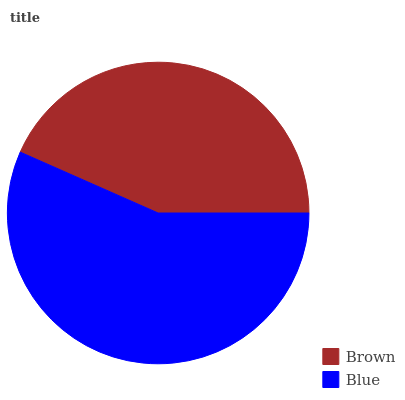Is Brown the minimum?
Answer yes or no. Yes. Is Blue the maximum?
Answer yes or no. Yes. Is Blue the minimum?
Answer yes or no. No. Is Blue greater than Brown?
Answer yes or no. Yes. Is Brown less than Blue?
Answer yes or no. Yes. Is Brown greater than Blue?
Answer yes or no. No. Is Blue less than Brown?
Answer yes or no. No. Is Blue the high median?
Answer yes or no. Yes. Is Brown the low median?
Answer yes or no. Yes. Is Brown the high median?
Answer yes or no. No. Is Blue the low median?
Answer yes or no. No. 